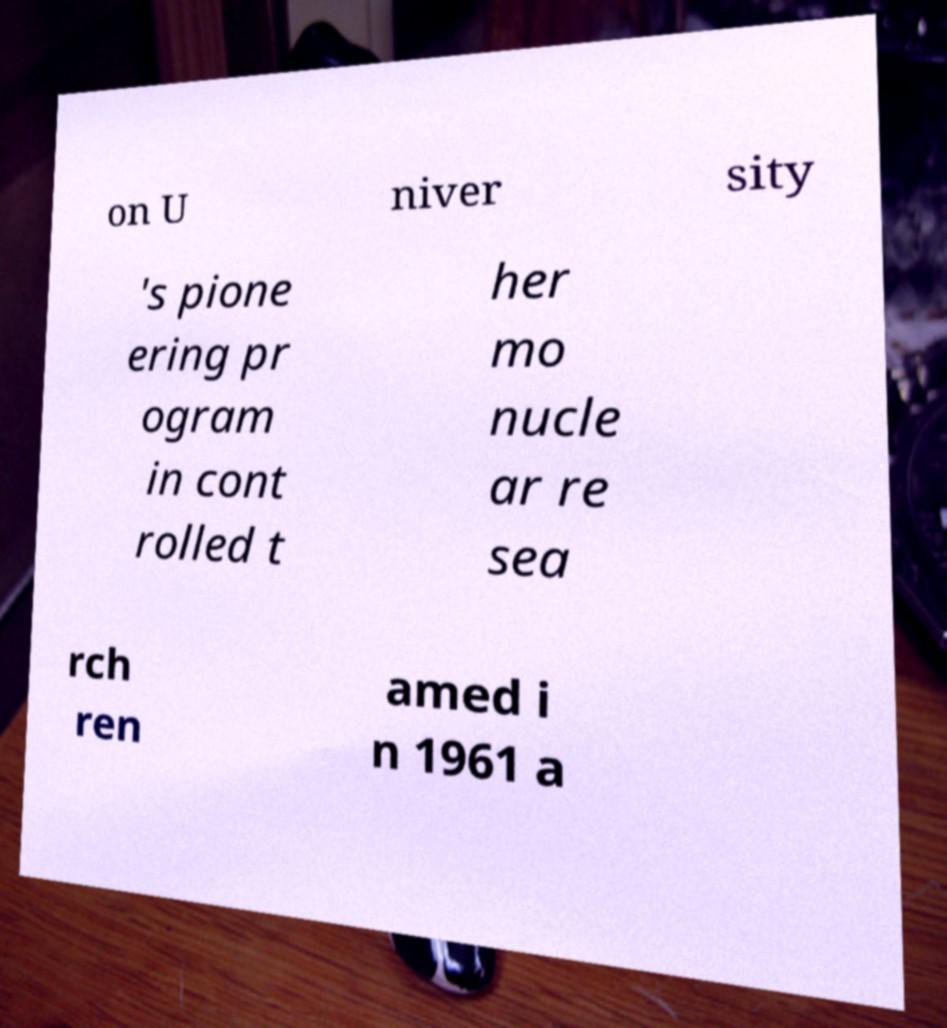Can you accurately transcribe the text from the provided image for me? on U niver sity 's pione ering pr ogram in cont rolled t her mo nucle ar re sea rch ren amed i n 1961 a 